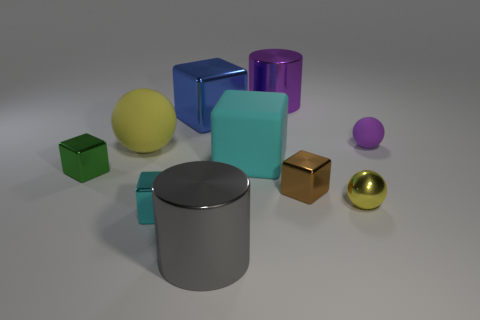Are there fewer gray things that are behind the brown shiny thing than tiny spheres?
Keep it short and to the point. Yes. How big is the purple thing left of the rubber ball that is on the right side of the yellow metal object?
Offer a very short reply. Large. There is a large metal block; does it have the same color as the large matte thing that is to the right of the big gray metal thing?
Offer a terse response. No. There is a cyan cube that is the same size as the yellow rubber thing; what is it made of?
Make the answer very short. Rubber. Are there fewer large cyan blocks that are left of the blue shiny cube than large yellow spheres in front of the large gray cylinder?
Give a very brief answer. No. There is a big blue metallic object that is to the left of the cylinder that is in front of the big metallic block; what is its shape?
Offer a terse response. Cube. Is there a cylinder?
Your response must be concise. Yes. The large shiny cylinder behind the tiny green metallic thing is what color?
Offer a terse response. Purple. There is another thing that is the same color as the small rubber thing; what is it made of?
Your response must be concise. Metal. Are there any cyan rubber things in front of the small brown cube?
Give a very brief answer. No. 